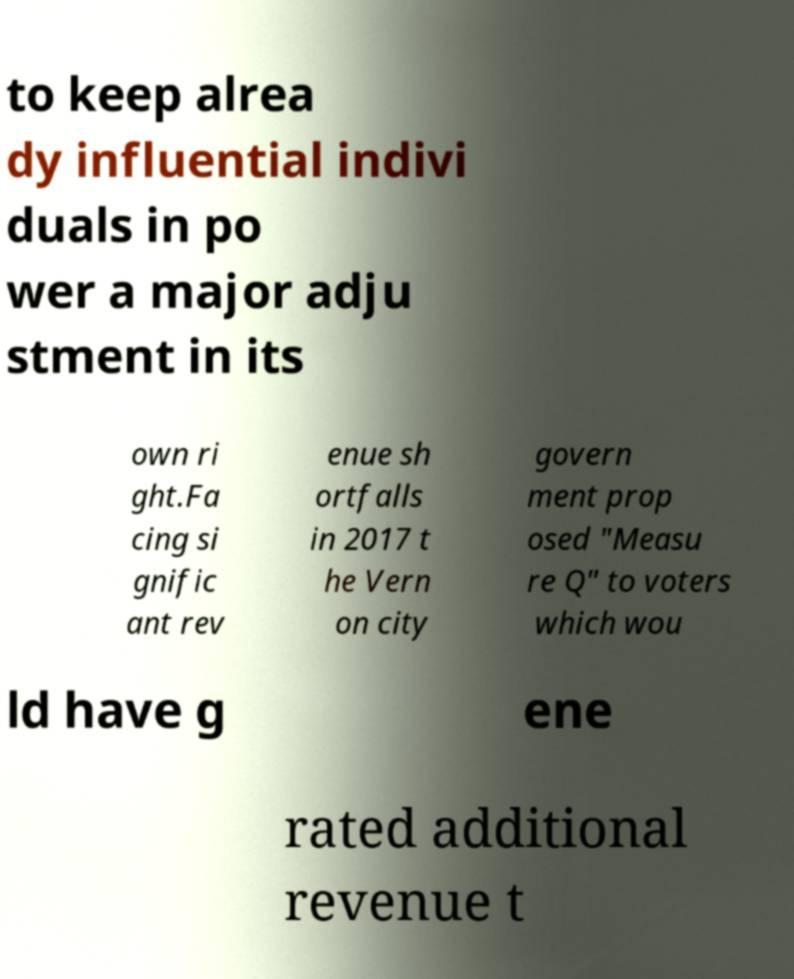Could you assist in decoding the text presented in this image and type it out clearly? to keep alrea dy influential indivi duals in po wer a major adju stment in its own ri ght.Fa cing si gnific ant rev enue sh ortfalls in 2017 t he Vern on city govern ment prop osed "Measu re Q" to voters which wou ld have g ene rated additional revenue t 